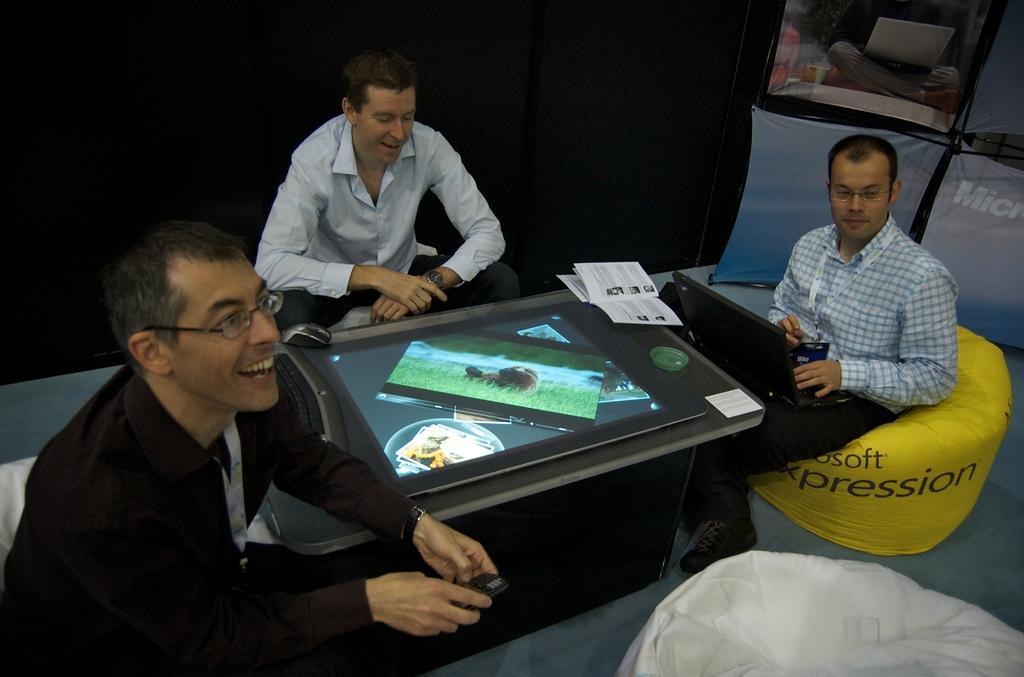How would you summarize this image in a sentence or two? In this image we can see three persons sitting in front of a table. One person wearing spectacles and black shirt. On the table we can see a screen, keyboard, mouse and a book. 